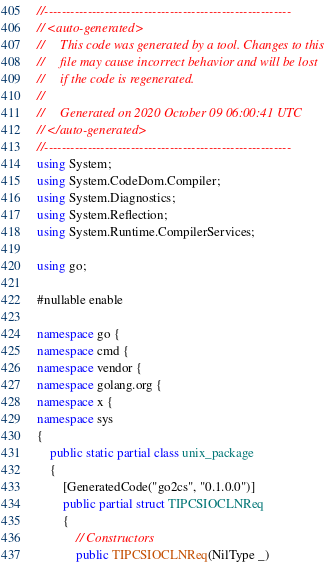Convert code to text. <code><loc_0><loc_0><loc_500><loc_500><_C#_>//---------------------------------------------------------
// <auto-generated>
//     This code was generated by a tool. Changes to this
//     file may cause incorrect behavior and will be lost
//     if the code is regenerated.
//
//     Generated on 2020 October 09 06:00:41 UTC
// </auto-generated>
//---------------------------------------------------------
using System;
using System.CodeDom.Compiler;
using System.Diagnostics;
using System.Reflection;
using System.Runtime.CompilerServices;

using go;

#nullable enable

namespace go {
namespace cmd {
namespace vendor {
namespace golang.org {
namespace x {
namespace sys
{
    public static partial class unix_package
    {
        [GeneratedCode("go2cs", "0.1.0.0")]
        public partial struct TIPCSIOCLNReq
        {
            // Constructors
            public TIPCSIOCLNReq(NilType _)</code> 